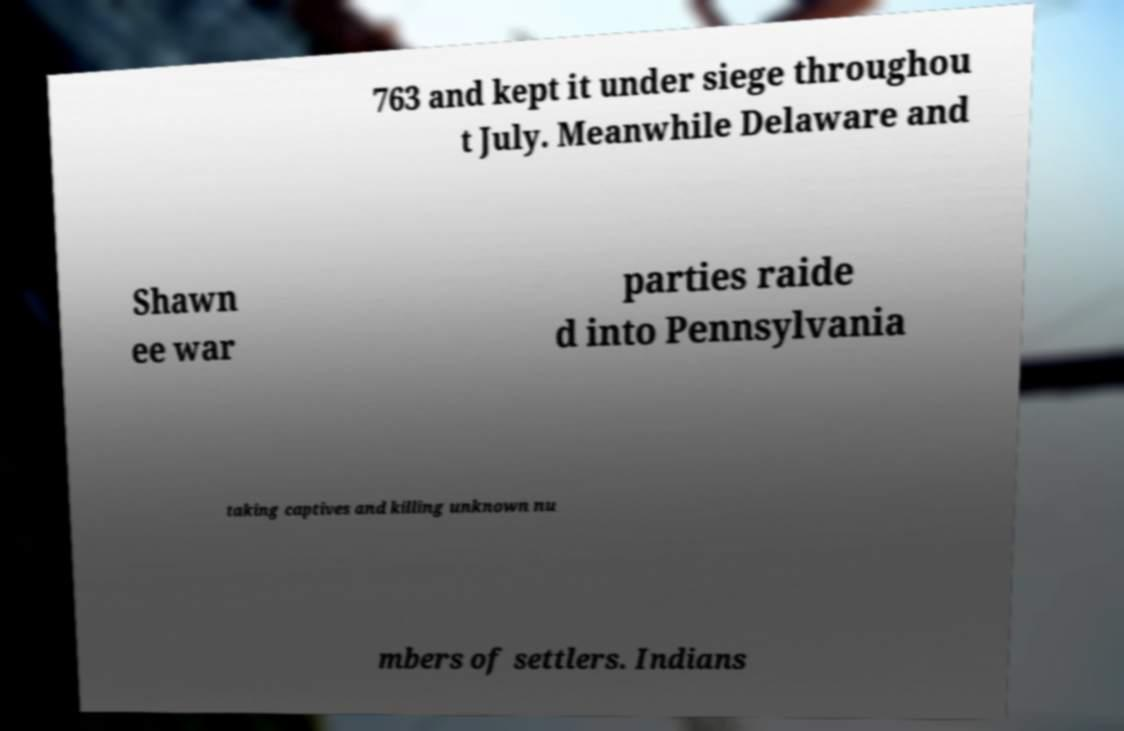Can you accurately transcribe the text from the provided image for me? 763 and kept it under siege throughou t July. Meanwhile Delaware and Shawn ee war parties raide d into Pennsylvania taking captives and killing unknown nu mbers of settlers. Indians 